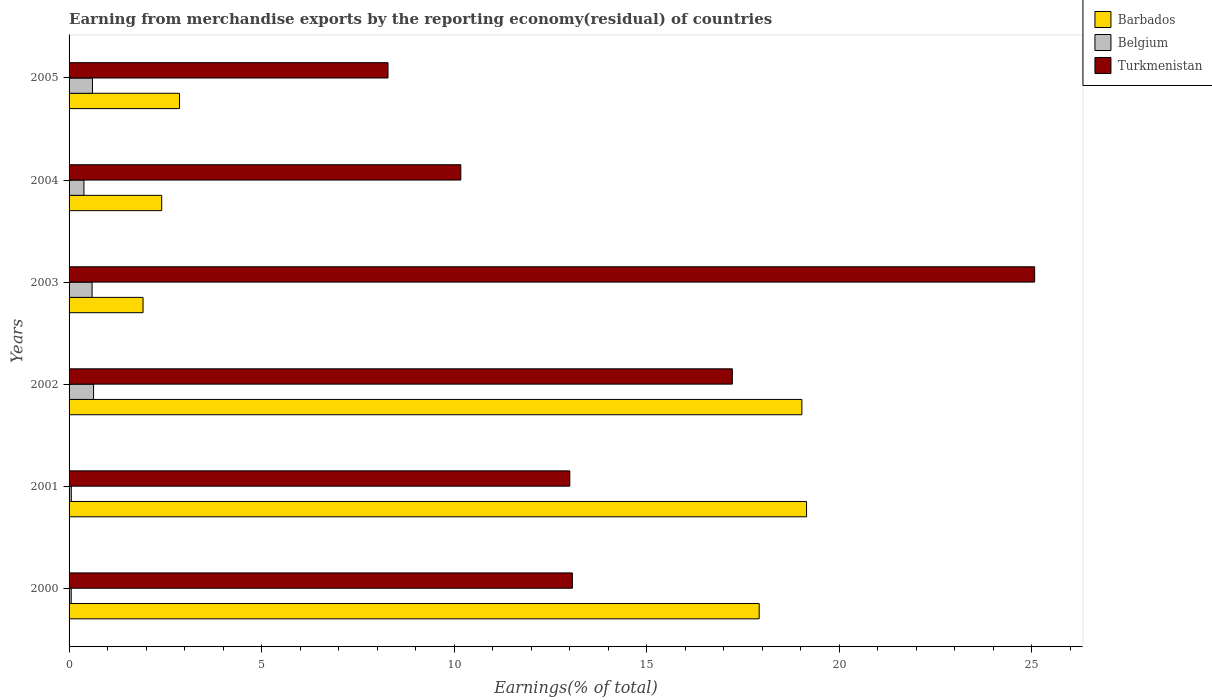How many bars are there on the 4th tick from the top?
Your response must be concise. 3. What is the label of the 4th group of bars from the top?
Offer a very short reply. 2002. What is the percentage of amount earned from merchandise exports in Turkmenistan in 2001?
Keep it short and to the point. 13. Across all years, what is the maximum percentage of amount earned from merchandise exports in Belgium?
Your answer should be compact. 0.64. Across all years, what is the minimum percentage of amount earned from merchandise exports in Belgium?
Provide a short and direct response. 0.06. In which year was the percentage of amount earned from merchandise exports in Turkmenistan minimum?
Your answer should be very brief. 2005. What is the total percentage of amount earned from merchandise exports in Turkmenistan in the graph?
Make the answer very short. 86.82. What is the difference between the percentage of amount earned from merchandise exports in Belgium in 2001 and that in 2004?
Your answer should be very brief. -0.33. What is the difference between the percentage of amount earned from merchandise exports in Turkmenistan in 2004 and the percentage of amount earned from merchandise exports in Barbados in 2000?
Your answer should be compact. -7.75. What is the average percentage of amount earned from merchandise exports in Turkmenistan per year?
Ensure brevity in your answer.  14.47. In the year 2004, what is the difference between the percentage of amount earned from merchandise exports in Barbados and percentage of amount earned from merchandise exports in Belgium?
Make the answer very short. 2.02. In how many years, is the percentage of amount earned from merchandise exports in Belgium greater than 9 %?
Offer a very short reply. 0. What is the ratio of the percentage of amount earned from merchandise exports in Barbados in 2001 to that in 2003?
Provide a short and direct response. 9.97. Is the difference between the percentage of amount earned from merchandise exports in Barbados in 2001 and 2002 greater than the difference between the percentage of amount earned from merchandise exports in Belgium in 2001 and 2002?
Provide a short and direct response. Yes. What is the difference between the highest and the second highest percentage of amount earned from merchandise exports in Turkmenistan?
Offer a very short reply. 7.85. What is the difference between the highest and the lowest percentage of amount earned from merchandise exports in Turkmenistan?
Provide a short and direct response. 16.79. In how many years, is the percentage of amount earned from merchandise exports in Barbados greater than the average percentage of amount earned from merchandise exports in Barbados taken over all years?
Make the answer very short. 3. Is the sum of the percentage of amount earned from merchandise exports in Barbados in 2003 and 2005 greater than the maximum percentage of amount earned from merchandise exports in Belgium across all years?
Your answer should be very brief. Yes. What does the 3rd bar from the top in 2001 represents?
Offer a terse response. Barbados. What does the 3rd bar from the bottom in 2002 represents?
Give a very brief answer. Turkmenistan. Is it the case that in every year, the sum of the percentage of amount earned from merchandise exports in Barbados and percentage of amount earned from merchandise exports in Belgium is greater than the percentage of amount earned from merchandise exports in Turkmenistan?
Ensure brevity in your answer.  No. How many bars are there?
Offer a terse response. 18. Are all the bars in the graph horizontal?
Provide a short and direct response. Yes. How many years are there in the graph?
Ensure brevity in your answer.  6. What is the difference between two consecutive major ticks on the X-axis?
Your answer should be very brief. 5. Does the graph contain any zero values?
Your answer should be compact. No. How are the legend labels stacked?
Provide a short and direct response. Vertical. What is the title of the graph?
Your answer should be very brief. Earning from merchandise exports by the reporting economy(residual) of countries. Does "St. Kitts and Nevis" appear as one of the legend labels in the graph?
Provide a short and direct response. No. What is the label or title of the X-axis?
Keep it short and to the point. Earnings(% of total). What is the Earnings(% of total) in Barbados in 2000?
Ensure brevity in your answer.  17.92. What is the Earnings(% of total) in Belgium in 2000?
Keep it short and to the point. 0.06. What is the Earnings(% of total) in Turkmenistan in 2000?
Offer a very short reply. 13.07. What is the Earnings(% of total) of Barbados in 2001?
Keep it short and to the point. 19.15. What is the Earnings(% of total) in Belgium in 2001?
Offer a terse response. 0.06. What is the Earnings(% of total) of Turkmenistan in 2001?
Offer a terse response. 13. What is the Earnings(% of total) of Barbados in 2002?
Give a very brief answer. 19.03. What is the Earnings(% of total) in Belgium in 2002?
Provide a short and direct response. 0.64. What is the Earnings(% of total) in Turkmenistan in 2002?
Give a very brief answer. 17.22. What is the Earnings(% of total) of Barbados in 2003?
Ensure brevity in your answer.  1.92. What is the Earnings(% of total) of Belgium in 2003?
Your response must be concise. 0.6. What is the Earnings(% of total) in Turkmenistan in 2003?
Your response must be concise. 25.07. What is the Earnings(% of total) of Barbados in 2004?
Provide a succinct answer. 2.41. What is the Earnings(% of total) of Belgium in 2004?
Offer a terse response. 0.39. What is the Earnings(% of total) of Turkmenistan in 2004?
Offer a terse response. 10.17. What is the Earnings(% of total) in Barbados in 2005?
Your answer should be compact. 2.87. What is the Earnings(% of total) in Belgium in 2005?
Offer a terse response. 0.61. What is the Earnings(% of total) in Turkmenistan in 2005?
Provide a short and direct response. 8.28. Across all years, what is the maximum Earnings(% of total) of Barbados?
Offer a terse response. 19.15. Across all years, what is the maximum Earnings(% of total) in Belgium?
Your answer should be compact. 0.64. Across all years, what is the maximum Earnings(% of total) of Turkmenistan?
Provide a short and direct response. 25.07. Across all years, what is the minimum Earnings(% of total) of Barbados?
Offer a terse response. 1.92. Across all years, what is the minimum Earnings(% of total) of Belgium?
Your response must be concise. 0.06. Across all years, what is the minimum Earnings(% of total) of Turkmenistan?
Provide a succinct answer. 8.28. What is the total Earnings(% of total) of Barbados in the graph?
Give a very brief answer. 63.29. What is the total Earnings(% of total) of Belgium in the graph?
Keep it short and to the point. 2.34. What is the total Earnings(% of total) of Turkmenistan in the graph?
Offer a terse response. 86.82. What is the difference between the Earnings(% of total) of Barbados in 2000 and that in 2001?
Your answer should be very brief. -1.23. What is the difference between the Earnings(% of total) in Belgium in 2000 and that in 2001?
Make the answer very short. -0. What is the difference between the Earnings(% of total) of Turkmenistan in 2000 and that in 2001?
Offer a very short reply. 0.07. What is the difference between the Earnings(% of total) of Barbados in 2000 and that in 2002?
Your answer should be very brief. -1.11. What is the difference between the Earnings(% of total) in Belgium in 2000 and that in 2002?
Provide a succinct answer. -0.58. What is the difference between the Earnings(% of total) of Turkmenistan in 2000 and that in 2002?
Provide a succinct answer. -4.15. What is the difference between the Earnings(% of total) in Barbados in 2000 and that in 2003?
Give a very brief answer. 16. What is the difference between the Earnings(% of total) of Belgium in 2000 and that in 2003?
Your response must be concise. -0.54. What is the difference between the Earnings(% of total) in Turkmenistan in 2000 and that in 2003?
Provide a short and direct response. -12. What is the difference between the Earnings(% of total) in Barbados in 2000 and that in 2004?
Offer a terse response. 15.51. What is the difference between the Earnings(% of total) of Belgium in 2000 and that in 2004?
Your answer should be compact. -0.33. What is the difference between the Earnings(% of total) of Turkmenistan in 2000 and that in 2004?
Make the answer very short. 2.9. What is the difference between the Earnings(% of total) in Barbados in 2000 and that in 2005?
Make the answer very short. 15.05. What is the difference between the Earnings(% of total) of Belgium in 2000 and that in 2005?
Provide a short and direct response. -0.55. What is the difference between the Earnings(% of total) of Turkmenistan in 2000 and that in 2005?
Offer a very short reply. 4.79. What is the difference between the Earnings(% of total) in Barbados in 2001 and that in 2002?
Provide a short and direct response. 0.12. What is the difference between the Earnings(% of total) of Belgium in 2001 and that in 2002?
Provide a succinct answer. -0.58. What is the difference between the Earnings(% of total) of Turkmenistan in 2001 and that in 2002?
Offer a terse response. -4.22. What is the difference between the Earnings(% of total) of Barbados in 2001 and that in 2003?
Your answer should be very brief. 17.23. What is the difference between the Earnings(% of total) of Belgium in 2001 and that in 2003?
Your answer should be compact. -0.54. What is the difference between the Earnings(% of total) in Turkmenistan in 2001 and that in 2003?
Your response must be concise. -12.07. What is the difference between the Earnings(% of total) in Barbados in 2001 and that in 2004?
Your answer should be very brief. 16.74. What is the difference between the Earnings(% of total) in Belgium in 2001 and that in 2004?
Ensure brevity in your answer.  -0.33. What is the difference between the Earnings(% of total) of Turkmenistan in 2001 and that in 2004?
Provide a succinct answer. 2.83. What is the difference between the Earnings(% of total) of Barbados in 2001 and that in 2005?
Ensure brevity in your answer.  16.28. What is the difference between the Earnings(% of total) of Belgium in 2001 and that in 2005?
Give a very brief answer. -0.55. What is the difference between the Earnings(% of total) of Turkmenistan in 2001 and that in 2005?
Your answer should be very brief. 4.72. What is the difference between the Earnings(% of total) of Barbados in 2002 and that in 2003?
Keep it short and to the point. 17.11. What is the difference between the Earnings(% of total) in Belgium in 2002 and that in 2003?
Provide a succinct answer. 0.04. What is the difference between the Earnings(% of total) in Turkmenistan in 2002 and that in 2003?
Keep it short and to the point. -7.85. What is the difference between the Earnings(% of total) in Barbados in 2002 and that in 2004?
Ensure brevity in your answer.  16.62. What is the difference between the Earnings(% of total) in Belgium in 2002 and that in 2004?
Your answer should be compact. 0.25. What is the difference between the Earnings(% of total) of Turkmenistan in 2002 and that in 2004?
Offer a very short reply. 7.05. What is the difference between the Earnings(% of total) of Barbados in 2002 and that in 2005?
Keep it short and to the point. 16.16. What is the difference between the Earnings(% of total) of Belgium in 2002 and that in 2005?
Give a very brief answer. 0.03. What is the difference between the Earnings(% of total) in Turkmenistan in 2002 and that in 2005?
Ensure brevity in your answer.  8.94. What is the difference between the Earnings(% of total) in Barbados in 2003 and that in 2004?
Provide a succinct answer. -0.48. What is the difference between the Earnings(% of total) in Belgium in 2003 and that in 2004?
Keep it short and to the point. 0.21. What is the difference between the Earnings(% of total) of Turkmenistan in 2003 and that in 2004?
Offer a terse response. 14.9. What is the difference between the Earnings(% of total) of Barbados in 2003 and that in 2005?
Your answer should be very brief. -0.95. What is the difference between the Earnings(% of total) in Belgium in 2003 and that in 2005?
Offer a terse response. -0.01. What is the difference between the Earnings(% of total) of Turkmenistan in 2003 and that in 2005?
Ensure brevity in your answer.  16.79. What is the difference between the Earnings(% of total) in Barbados in 2004 and that in 2005?
Ensure brevity in your answer.  -0.46. What is the difference between the Earnings(% of total) in Belgium in 2004 and that in 2005?
Offer a terse response. -0.22. What is the difference between the Earnings(% of total) of Turkmenistan in 2004 and that in 2005?
Give a very brief answer. 1.89. What is the difference between the Earnings(% of total) of Barbados in 2000 and the Earnings(% of total) of Belgium in 2001?
Your answer should be compact. 17.86. What is the difference between the Earnings(% of total) in Barbados in 2000 and the Earnings(% of total) in Turkmenistan in 2001?
Your answer should be very brief. 4.92. What is the difference between the Earnings(% of total) of Belgium in 2000 and the Earnings(% of total) of Turkmenistan in 2001?
Give a very brief answer. -12.95. What is the difference between the Earnings(% of total) in Barbados in 2000 and the Earnings(% of total) in Belgium in 2002?
Offer a terse response. 17.28. What is the difference between the Earnings(% of total) in Barbados in 2000 and the Earnings(% of total) in Turkmenistan in 2002?
Give a very brief answer. 0.7. What is the difference between the Earnings(% of total) in Belgium in 2000 and the Earnings(% of total) in Turkmenistan in 2002?
Make the answer very short. -17.17. What is the difference between the Earnings(% of total) in Barbados in 2000 and the Earnings(% of total) in Belgium in 2003?
Provide a short and direct response. 17.32. What is the difference between the Earnings(% of total) in Barbados in 2000 and the Earnings(% of total) in Turkmenistan in 2003?
Make the answer very short. -7.15. What is the difference between the Earnings(% of total) in Belgium in 2000 and the Earnings(% of total) in Turkmenistan in 2003?
Provide a succinct answer. -25.02. What is the difference between the Earnings(% of total) in Barbados in 2000 and the Earnings(% of total) in Belgium in 2004?
Give a very brief answer. 17.53. What is the difference between the Earnings(% of total) of Barbados in 2000 and the Earnings(% of total) of Turkmenistan in 2004?
Give a very brief answer. 7.75. What is the difference between the Earnings(% of total) in Belgium in 2000 and the Earnings(% of total) in Turkmenistan in 2004?
Give a very brief answer. -10.12. What is the difference between the Earnings(% of total) of Barbados in 2000 and the Earnings(% of total) of Belgium in 2005?
Keep it short and to the point. 17.31. What is the difference between the Earnings(% of total) in Barbados in 2000 and the Earnings(% of total) in Turkmenistan in 2005?
Offer a very short reply. 9.64. What is the difference between the Earnings(% of total) in Belgium in 2000 and the Earnings(% of total) in Turkmenistan in 2005?
Make the answer very short. -8.23. What is the difference between the Earnings(% of total) of Barbados in 2001 and the Earnings(% of total) of Belgium in 2002?
Provide a succinct answer. 18.51. What is the difference between the Earnings(% of total) of Barbados in 2001 and the Earnings(% of total) of Turkmenistan in 2002?
Your response must be concise. 1.93. What is the difference between the Earnings(% of total) in Belgium in 2001 and the Earnings(% of total) in Turkmenistan in 2002?
Your response must be concise. -17.16. What is the difference between the Earnings(% of total) of Barbados in 2001 and the Earnings(% of total) of Belgium in 2003?
Your response must be concise. 18.55. What is the difference between the Earnings(% of total) in Barbados in 2001 and the Earnings(% of total) in Turkmenistan in 2003?
Your response must be concise. -5.92. What is the difference between the Earnings(% of total) in Belgium in 2001 and the Earnings(% of total) in Turkmenistan in 2003?
Make the answer very short. -25.01. What is the difference between the Earnings(% of total) of Barbados in 2001 and the Earnings(% of total) of Belgium in 2004?
Make the answer very short. 18.76. What is the difference between the Earnings(% of total) in Barbados in 2001 and the Earnings(% of total) in Turkmenistan in 2004?
Your answer should be compact. 8.98. What is the difference between the Earnings(% of total) in Belgium in 2001 and the Earnings(% of total) in Turkmenistan in 2004?
Your response must be concise. -10.11. What is the difference between the Earnings(% of total) of Barbados in 2001 and the Earnings(% of total) of Belgium in 2005?
Your answer should be compact. 18.54. What is the difference between the Earnings(% of total) of Barbados in 2001 and the Earnings(% of total) of Turkmenistan in 2005?
Your response must be concise. 10.87. What is the difference between the Earnings(% of total) in Belgium in 2001 and the Earnings(% of total) in Turkmenistan in 2005?
Provide a succinct answer. -8.22. What is the difference between the Earnings(% of total) in Barbados in 2002 and the Earnings(% of total) in Belgium in 2003?
Your answer should be compact. 18.43. What is the difference between the Earnings(% of total) of Barbados in 2002 and the Earnings(% of total) of Turkmenistan in 2003?
Your response must be concise. -6.04. What is the difference between the Earnings(% of total) of Belgium in 2002 and the Earnings(% of total) of Turkmenistan in 2003?
Your answer should be compact. -24.44. What is the difference between the Earnings(% of total) in Barbados in 2002 and the Earnings(% of total) in Belgium in 2004?
Your answer should be compact. 18.64. What is the difference between the Earnings(% of total) in Barbados in 2002 and the Earnings(% of total) in Turkmenistan in 2004?
Offer a very short reply. 8.86. What is the difference between the Earnings(% of total) in Belgium in 2002 and the Earnings(% of total) in Turkmenistan in 2004?
Ensure brevity in your answer.  -9.54. What is the difference between the Earnings(% of total) in Barbados in 2002 and the Earnings(% of total) in Belgium in 2005?
Provide a succinct answer. 18.42. What is the difference between the Earnings(% of total) in Barbados in 2002 and the Earnings(% of total) in Turkmenistan in 2005?
Provide a short and direct response. 10.75. What is the difference between the Earnings(% of total) in Belgium in 2002 and the Earnings(% of total) in Turkmenistan in 2005?
Provide a succinct answer. -7.65. What is the difference between the Earnings(% of total) of Barbados in 2003 and the Earnings(% of total) of Belgium in 2004?
Give a very brief answer. 1.54. What is the difference between the Earnings(% of total) of Barbados in 2003 and the Earnings(% of total) of Turkmenistan in 2004?
Provide a short and direct response. -8.25. What is the difference between the Earnings(% of total) in Belgium in 2003 and the Earnings(% of total) in Turkmenistan in 2004?
Your response must be concise. -9.57. What is the difference between the Earnings(% of total) in Barbados in 2003 and the Earnings(% of total) in Belgium in 2005?
Your answer should be very brief. 1.31. What is the difference between the Earnings(% of total) in Barbados in 2003 and the Earnings(% of total) in Turkmenistan in 2005?
Ensure brevity in your answer.  -6.36. What is the difference between the Earnings(% of total) of Belgium in 2003 and the Earnings(% of total) of Turkmenistan in 2005?
Offer a terse response. -7.68. What is the difference between the Earnings(% of total) of Barbados in 2004 and the Earnings(% of total) of Belgium in 2005?
Your response must be concise. 1.8. What is the difference between the Earnings(% of total) in Barbados in 2004 and the Earnings(% of total) in Turkmenistan in 2005?
Your answer should be very brief. -5.88. What is the difference between the Earnings(% of total) of Belgium in 2004 and the Earnings(% of total) of Turkmenistan in 2005?
Your answer should be compact. -7.9. What is the average Earnings(% of total) in Barbados per year?
Make the answer very short. 10.55. What is the average Earnings(% of total) of Belgium per year?
Keep it short and to the point. 0.39. What is the average Earnings(% of total) in Turkmenistan per year?
Offer a very short reply. 14.47. In the year 2000, what is the difference between the Earnings(% of total) in Barbados and Earnings(% of total) in Belgium?
Ensure brevity in your answer.  17.86. In the year 2000, what is the difference between the Earnings(% of total) in Barbados and Earnings(% of total) in Turkmenistan?
Your answer should be compact. 4.85. In the year 2000, what is the difference between the Earnings(% of total) in Belgium and Earnings(% of total) in Turkmenistan?
Provide a short and direct response. -13.01. In the year 2001, what is the difference between the Earnings(% of total) in Barbados and Earnings(% of total) in Belgium?
Your answer should be very brief. 19.09. In the year 2001, what is the difference between the Earnings(% of total) in Barbados and Earnings(% of total) in Turkmenistan?
Provide a succinct answer. 6.15. In the year 2001, what is the difference between the Earnings(% of total) of Belgium and Earnings(% of total) of Turkmenistan?
Your response must be concise. -12.94. In the year 2002, what is the difference between the Earnings(% of total) of Barbados and Earnings(% of total) of Belgium?
Give a very brief answer. 18.39. In the year 2002, what is the difference between the Earnings(% of total) in Barbados and Earnings(% of total) in Turkmenistan?
Your answer should be very brief. 1.81. In the year 2002, what is the difference between the Earnings(% of total) in Belgium and Earnings(% of total) in Turkmenistan?
Your response must be concise. -16.59. In the year 2003, what is the difference between the Earnings(% of total) of Barbados and Earnings(% of total) of Belgium?
Provide a short and direct response. 1.32. In the year 2003, what is the difference between the Earnings(% of total) of Barbados and Earnings(% of total) of Turkmenistan?
Give a very brief answer. -23.15. In the year 2003, what is the difference between the Earnings(% of total) in Belgium and Earnings(% of total) in Turkmenistan?
Your response must be concise. -24.48. In the year 2004, what is the difference between the Earnings(% of total) of Barbados and Earnings(% of total) of Belgium?
Ensure brevity in your answer.  2.02. In the year 2004, what is the difference between the Earnings(% of total) of Barbados and Earnings(% of total) of Turkmenistan?
Make the answer very short. -7.77. In the year 2004, what is the difference between the Earnings(% of total) in Belgium and Earnings(% of total) in Turkmenistan?
Provide a short and direct response. -9.79. In the year 2005, what is the difference between the Earnings(% of total) in Barbados and Earnings(% of total) in Belgium?
Offer a very short reply. 2.26. In the year 2005, what is the difference between the Earnings(% of total) of Barbados and Earnings(% of total) of Turkmenistan?
Your answer should be compact. -5.41. In the year 2005, what is the difference between the Earnings(% of total) in Belgium and Earnings(% of total) in Turkmenistan?
Offer a terse response. -7.67. What is the ratio of the Earnings(% of total) of Barbados in 2000 to that in 2001?
Make the answer very short. 0.94. What is the ratio of the Earnings(% of total) in Belgium in 2000 to that in 2001?
Your answer should be compact. 0.95. What is the ratio of the Earnings(% of total) of Barbados in 2000 to that in 2002?
Your answer should be very brief. 0.94. What is the ratio of the Earnings(% of total) of Belgium in 2000 to that in 2002?
Give a very brief answer. 0.09. What is the ratio of the Earnings(% of total) of Turkmenistan in 2000 to that in 2002?
Offer a very short reply. 0.76. What is the ratio of the Earnings(% of total) of Barbados in 2000 to that in 2003?
Your answer should be very brief. 9.33. What is the ratio of the Earnings(% of total) in Belgium in 2000 to that in 2003?
Your response must be concise. 0.09. What is the ratio of the Earnings(% of total) of Turkmenistan in 2000 to that in 2003?
Your answer should be compact. 0.52. What is the ratio of the Earnings(% of total) in Barbados in 2000 to that in 2004?
Your answer should be very brief. 7.45. What is the ratio of the Earnings(% of total) in Belgium in 2000 to that in 2004?
Your answer should be very brief. 0.14. What is the ratio of the Earnings(% of total) in Turkmenistan in 2000 to that in 2004?
Keep it short and to the point. 1.28. What is the ratio of the Earnings(% of total) of Barbados in 2000 to that in 2005?
Keep it short and to the point. 6.25. What is the ratio of the Earnings(% of total) of Belgium in 2000 to that in 2005?
Keep it short and to the point. 0.09. What is the ratio of the Earnings(% of total) in Turkmenistan in 2000 to that in 2005?
Give a very brief answer. 1.58. What is the ratio of the Earnings(% of total) of Barbados in 2001 to that in 2002?
Keep it short and to the point. 1.01. What is the ratio of the Earnings(% of total) of Belgium in 2001 to that in 2002?
Your answer should be very brief. 0.09. What is the ratio of the Earnings(% of total) of Turkmenistan in 2001 to that in 2002?
Offer a very short reply. 0.75. What is the ratio of the Earnings(% of total) of Barbados in 2001 to that in 2003?
Your response must be concise. 9.97. What is the ratio of the Earnings(% of total) of Belgium in 2001 to that in 2003?
Keep it short and to the point. 0.1. What is the ratio of the Earnings(% of total) of Turkmenistan in 2001 to that in 2003?
Your answer should be compact. 0.52. What is the ratio of the Earnings(% of total) in Barbados in 2001 to that in 2004?
Give a very brief answer. 7.96. What is the ratio of the Earnings(% of total) of Belgium in 2001 to that in 2004?
Offer a very short reply. 0.15. What is the ratio of the Earnings(% of total) of Turkmenistan in 2001 to that in 2004?
Give a very brief answer. 1.28. What is the ratio of the Earnings(% of total) in Barbados in 2001 to that in 2005?
Your response must be concise. 6.68. What is the ratio of the Earnings(% of total) in Belgium in 2001 to that in 2005?
Your response must be concise. 0.1. What is the ratio of the Earnings(% of total) in Turkmenistan in 2001 to that in 2005?
Your answer should be very brief. 1.57. What is the ratio of the Earnings(% of total) in Barbados in 2002 to that in 2003?
Give a very brief answer. 9.9. What is the ratio of the Earnings(% of total) in Belgium in 2002 to that in 2003?
Provide a succinct answer. 1.06. What is the ratio of the Earnings(% of total) of Turkmenistan in 2002 to that in 2003?
Give a very brief answer. 0.69. What is the ratio of the Earnings(% of total) in Barbados in 2002 to that in 2004?
Give a very brief answer. 7.91. What is the ratio of the Earnings(% of total) in Belgium in 2002 to that in 2004?
Provide a short and direct response. 1.65. What is the ratio of the Earnings(% of total) in Turkmenistan in 2002 to that in 2004?
Keep it short and to the point. 1.69. What is the ratio of the Earnings(% of total) of Barbados in 2002 to that in 2005?
Give a very brief answer. 6.63. What is the ratio of the Earnings(% of total) in Belgium in 2002 to that in 2005?
Your response must be concise. 1.05. What is the ratio of the Earnings(% of total) in Turkmenistan in 2002 to that in 2005?
Give a very brief answer. 2.08. What is the ratio of the Earnings(% of total) in Barbados in 2003 to that in 2004?
Give a very brief answer. 0.8. What is the ratio of the Earnings(% of total) of Belgium in 2003 to that in 2004?
Offer a terse response. 1.55. What is the ratio of the Earnings(% of total) in Turkmenistan in 2003 to that in 2004?
Your answer should be compact. 2.46. What is the ratio of the Earnings(% of total) in Barbados in 2003 to that in 2005?
Ensure brevity in your answer.  0.67. What is the ratio of the Earnings(% of total) of Belgium in 2003 to that in 2005?
Give a very brief answer. 0.98. What is the ratio of the Earnings(% of total) in Turkmenistan in 2003 to that in 2005?
Give a very brief answer. 3.03. What is the ratio of the Earnings(% of total) of Barbados in 2004 to that in 2005?
Your response must be concise. 0.84. What is the ratio of the Earnings(% of total) in Belgium in 2004 to that in 2005?
Offer a very short reply. 0.64. What is the ratio of the Earnings(% of total) in Turkmenistan in 2004 to that in 2005?
Ensure brevity in your answer.  1.23. What is the difference between the highest and the second highest Earnings(% of total) of Barbados?
Give a very brief answer. 0.12. What is the difference between the highest and the second highest Earnings(% of total) of Belgium?
Your response must be concise. 0.03. What is the difference between the highest and the second highest Earnings(% of total) in Turkmenistan?
Provide a succinct answer. 7.85. What is the difference between the highest and the lowest Earnings(% of total) in Barbados?
Make the answer very short. 17.23. What is the difference between the highest and the lowest Earnings(% of total) in Belgium?
Your answer should be compact. 0.58. What is the difference between the highest and the lowest Earnings(% of total) of Turkmenistan?
Offer a terse response. 16.79. 